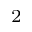<formula> <loc_0><loc_0><loc_500><loc_500>_ { 2 }</formula> 